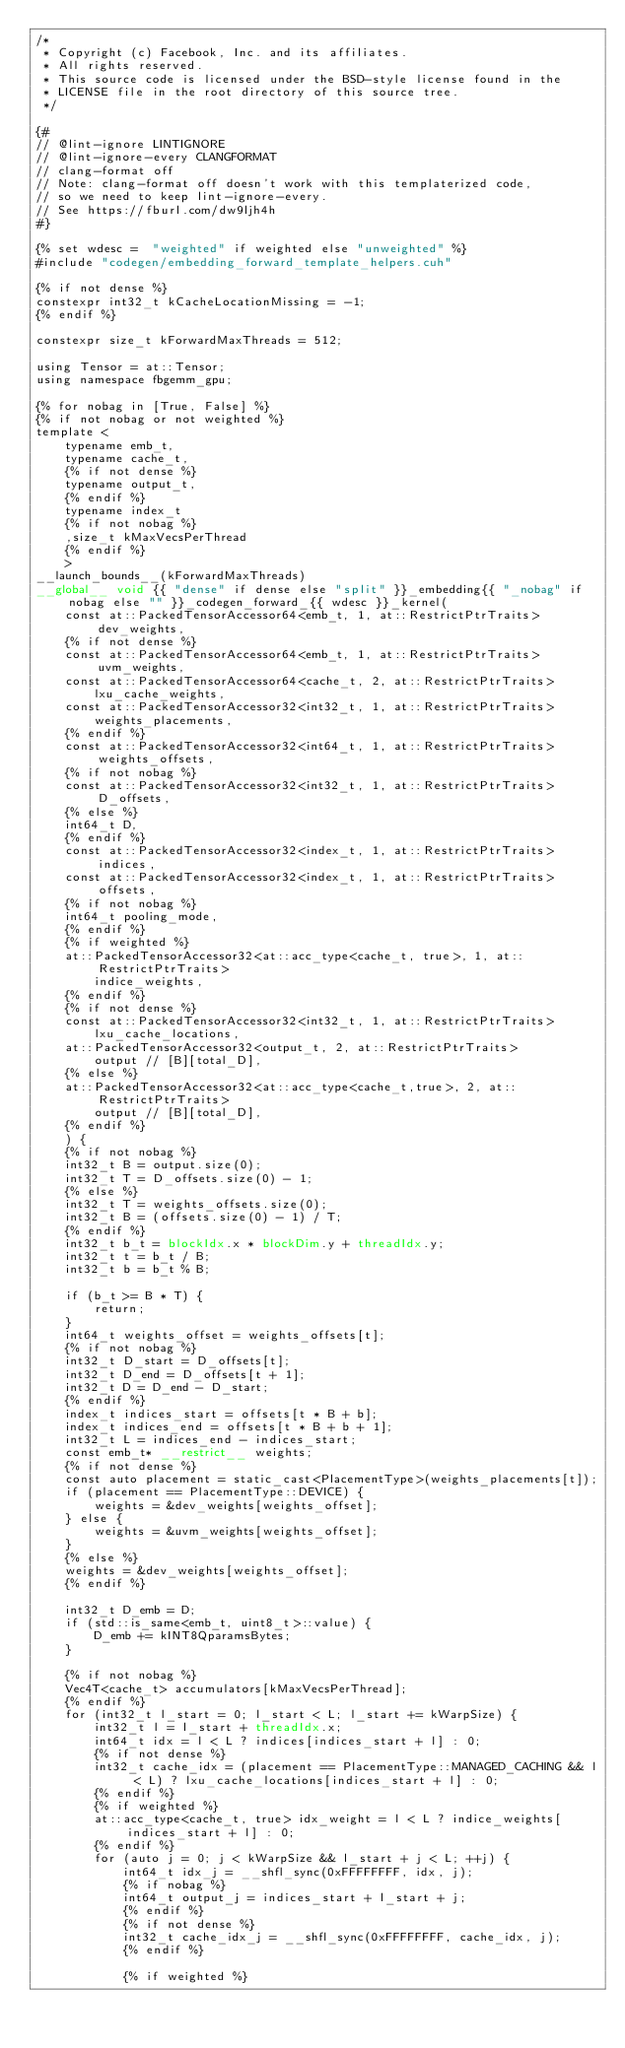<code> <loc_0><loc_0><loc_500><loc_500><_Cuda_>/*
 * Copyright (c) Facebook, Inc. and its affiliates.
 * All rights reserved.
 * This source code is licensed under the BSD-style license found in the
 * LICENSE file in the root directory of this source tree.
 */

{#
// @lint-ignore LINTIGNORE
// @lint-ignore-every CLANGFORMAT
// clang-format off
// Note: clang-format off doesn't work with this templaterized code,
// so we need to keep lint-ignore-every.
// See https://fburl.com/dw9ljh4h
#}

{% set wdesc =  "weighted" if weighted else "unweighted" %}
#include "codegen/embedding_forward_template_helpers.cuh"

{% if not dense %}
constexpr int32_t kCacheLocationMissing = -1;
{% endif %}

constexpr size_t kForwardMaxThreads = 512;

using Tensor = at::Tensor;
using namespace fbgemm_gpu;

{% for nobag in [True, False] %}
{% if not nobag or not weighted %}
template <
    typename emb_t,
    typename cache_t,
    {% if not dense %}
    typename output_t,
    {% endif %}
    typename index_t
    {% if not nobag %}
    ,size_t kMaxVecsPerThread
    {% endif %}
    >
__launch_bounds__(kForwardMaxThreads)
__global__ void {{ "dense" if dense else "split" }}_embedding{{ "_nobag" if nobag else "" }}_codegen_forward_{{ wdesc }}_kernel(
    const at::PackedTensorAccessor64<emb_t, 1, at::RestrictPtrTraits> dev_weights,
    {% if not dense %}
    const at::PackedTensorAccessor64<emb_t, 1, at::RestrictPtrTraits> uvm_weights,
    const at::PackedTensorAccessor64<cache_t, 2, at::RestrictPtrTraits>
        lxu_cache_weights,
    const at::PackedTensorAccessor32<int32_t, 1, at::RestrictPtrTraits>
        weights_placements,
    {% endif %}
    const at::PackedTensorAccessor32<int64_t, 1, at::RestrictPtrTraits> weights_offsets,
    {% if not nobag %}
    const at::PackedTensorAccessor32<int32_t, 1, at::RestrictPtrTraits> D_offsets,
    {% else %}
    int64_t D,
    {% endif %}
    const at::PackedTensorAccessor32<index_t, 1, at::RestrictPtrTraits> indices,
    const at::PackedTensorAccessor32<index_t, 1, at::RestrictPtrTraits> offsets,
    {% if not nobag %}
    int64_t pooling_mode,
    {% endif %}
    {% if weighted %}
    at::PackedTensorAccessor32<at::acc_type<cache_t, true>, 1, at::RestrictPtrTraits>
        indice_weights,
    {% endif %}
    {% if not dense %}
    const at::PackedTensorAccessor32<int32_t, 1, at::RestrictPtrTraits>
        lxu_cache_locations,
    at::PackedTensorAccessor32<output_t, 2, at::RestrictPtrTraits>
        output // [B][total_D],
    {% else %}
    at::PackedTensorAccessor32<at::acc_type<cache_t,true>, 2, at::RestrictPtrTraits>
        output // [B][total_D],
    {% endif %}
    ) {
    {% if not nobag %}
    int32_t B = output.size(0);
    int32_t T = D_offsets.size(0) - 1;
    {% else %}
    int32_t T = weights_offsets.size(0);
    int32_t B = (offsets.size(0) - 1) / T;
    {% endif %}
    int32_t b_t = blockIdx.x * blockDim.y + threadIdx.y;
    int32_t t = b_t / B;
    int32_t b = b_t % B;

    if (b_t >= B * T) {
        return;
    }
    int64_t weights_offset = weights_offsets[t];
    {% if not nobag %}
    int32_t D_start = D_offsets[t];
    int32_t D_end = D_offsets[t + 1];
    int32_t D = D_end - D_start;
    {% endif %}
    index_t indices_start = offsets[t * B + b];
    index_t indices_end = offsets[t * B + b + 1];
    int32_t L = indices_end - indices_start;
    const emb_t* __restrict__ weights;
    {% if not dense %}
    const auto placement = static_cast<PlacementType>(weights_placements[t]);
    if (placement == PlacementType::DEVICE) {
        weights = &dev_weights[weights_offset];
    } else {
        weights = &uvm_weights[weights_offset];
    }
    {% else %}
    weights = &dev_weights[weights_offset];
    {% endif %}

    int32_t D_emb = D;
    if (std::is_same<emb_t, uint8_t>::value) {
        D_emb += kINT8QparamsBytes;
    }

    {% if not nobag %}
    Vec4T<cache_t> accumulators[kMaxVecsPerThread];
    {% endif %}
    for (int32_t l_start = 0; l_start < L; l_start += kWarpSize) {
        int32_t l = l_start + threadIdx.x;
        int64_t idx = l < L ? indices[indices_start + l] : 0;
        {% if not dense %}
        int32_t cache_idx = (placement == PlacementType::MANAGED_CACHING && l < L) ? lxu_cache_locations[indices_start + l] : 0;
        {% endif %}
        {% if weighted %}
        at::acc_type<cache_t, true> idx_weight = l < L ? indice_weights[indices_start + l] : 0;
        {% endif %}
        for (auto j = 0; j < kWarpSize && l_start + j < L; ++j) {
            int64_t idx_j = __shfl_sync(0xFFFFFFFF, idx, j);
            {% if nobag %}
            int64_t output_j = indices_start + l_start + j;
            {% endif %}
            {% if not dense %}
            int32_t cache_idx_j = __shfl_sync(0xFFFFFFFF, cache_idx, j);
            {% endif %}

            {% if weighted %}</code> 